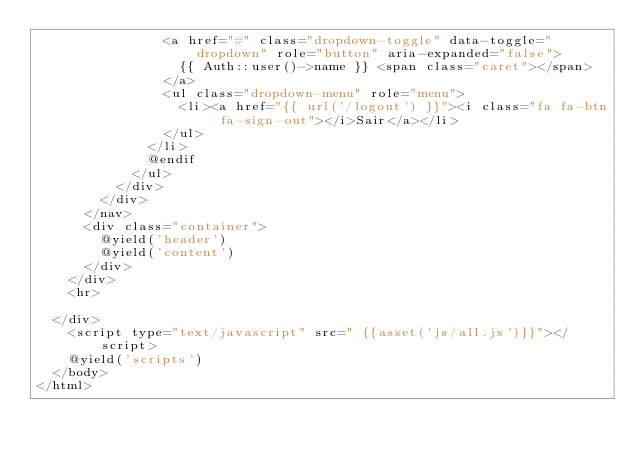<code> <loc_0><loc_0><loc_500><loc_500><_PHP_>								<a href="#" class="dropdown-toggle" data-toggle="dropdown" role="button" aria-expanded="false">
									{{ Auth::user()->name }} <span class="caret"></span>
								</a>
								<ul class="dropdown-menu" role="menu">
									<li><a href="{{ url('/logout') }}"><i class="fa fa-btn fa-sign-out"></i>Sair</a></li>
								</ul>
							</li>
							@endif
						</ul>
					</div>
				</div>
			</nav>
			<div class="container">
				@yield('header')
				@yield('content')
			</div>
		</div>
		<hr>

	</div>
		<script type="text/javascript" src=" {{asset('js/all.js')}}"></script>
		@yield('scripts')
	</body>
</html>


</code> 